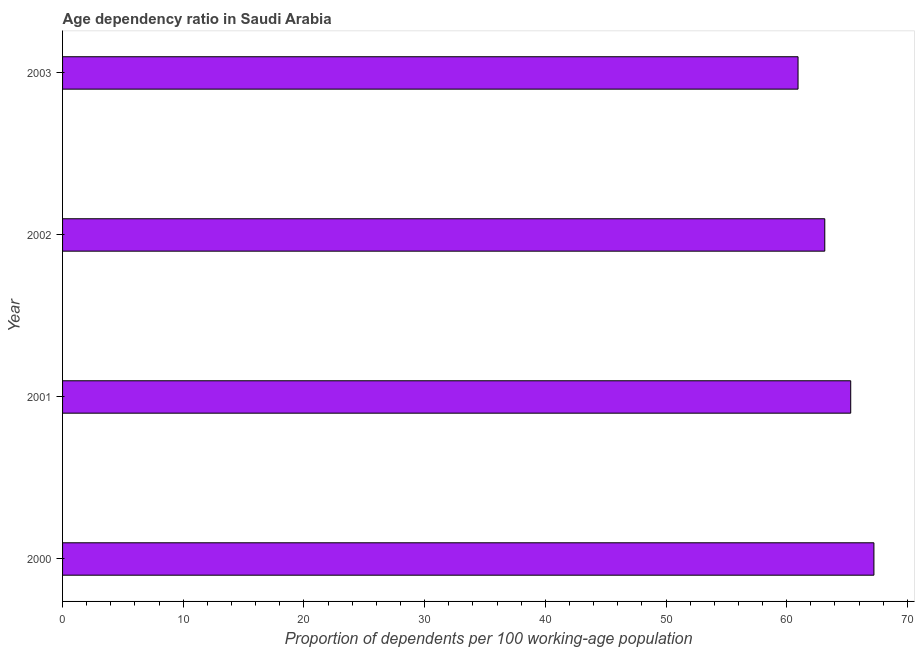Does the graph contain any zero values?
Your answer should be very brief. No. What is the title of the graph?
Your answer should be very brief. Age dependency ratio in Saudi Arabia. What is the label or title of the X-axis?
Ensure brevity in your answer.  Proportion of dependents per 100 working-age population. What is the label or title of the Y-axis?
Ensure brevity in your answer.  Year. What is the age dependency ratio in 2003?
Provide a succinct answer. 60.94. Across all years, what is the maximum age dependency ratio?
Your answer should be very brief. 67.23. Across all years, what is the minimum age dependency ratio?
Offer a very short reply. 60.94. In which year was the age dependency ratio maximum?
Offer a terse response. 2000. What is the sum of the age dependency ratio?
Offer a very short reply. 256.63. What is the difference between the age dependency ratio in 2000 and 2002?
Offer a terse response. 4.07. What is the average age dependency ratio per year?
Your answer should be compact. 64.16. What is the median age dependency ratio?
Keep it short and to the point. 64.23. What is the ratio of the age dependency ratio in 2001 to that in 2003?
Keep it short and to the point. 1.07. Is the age dependency ratio in 2002 less than that in 2003?
Your response must be concise. No. What is the difference between the highest and the second highest age dependency ratio?
Offer a very short reply. 1.92. What is the difference between the highest and the lowest age dependency ratio?
Offer a terse response. 6.29. Are the values on the major ticks of X-axis written in scientific E-notation?
Provide a short and direct response. No. What is the Proportion of dependents per 100 working-age population in 2000?
Provide a short and direct response. 67.23. What is the Proportion of dependents per 100 working-age population of 2001?
Provide a succinct answer. 65.3. What is the Proportion of dependents per 100 working-age population of 2002?
Give a very brief answer. 63.16. What is the Proportion of dependents per 100 working-age population of 2003?
Provide a succinct answer. 60.94. What is the difference between the Proportion of dependents per 100 working-age population in 2000 and 2001?
Offer a very short reply. 1.92. What is the difference between the Proportion of dependents per 100 working-age population in 2000 and 2002?
Provide a succinct answer. 4.07. What is the difference between the Proportion of dependents per 100 working-age population in 2000 and 2003?
Ensure brevity in your answer.  6.29. What is the difference between the Proportion of dependents per 100 working-age population in 2001 and 2002?
Offer a terse response. 2.15. What is the difference between the Proportion of dependents per 100 working-age population in 2001 and 2003?
Ensure brevity in your answer.  4.36. What is the difference between the Proportion of dependents per 100 working-age population in 2002 and 2003?
Ensure brevity in your answer.  2.22. What is the ratio of the Proportion of dependents per 100 working-age population in 2000 to that in 2002?
Your response must be concise. 1.06. What is the ratio of the Proportion of dependents per 100 working-age population in 2000 to that in 2003?
Offer a very short reply. 1.1. What is the ratio of the Proportion of dependents per 100 working-age population in 2001 to that in 2002?
Give a very brief answer. 1.03. What is the ratio of the Proportion of dependents per 100 working-age population in 2001 to that in 2003?
Your answer should be very brief. 1.07. What is the ratio of the Proportion of dependents per 100 working-age population in 2002 to that in 2003?
Your answer should be very brief. 1.04. 